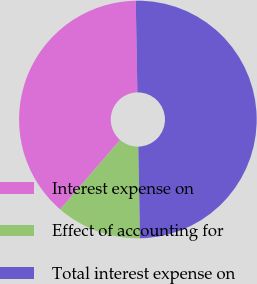Convert chart. <chart><loc_0><loc_0><loc_500><loc_500><pie_chart><fcel>Interest expense on<fcel>Effect of accounting for<fcel>Total interest expense on<nl><fcel>38.37%<fcel>11.63%<fcel>50.0%<nl></chart> 